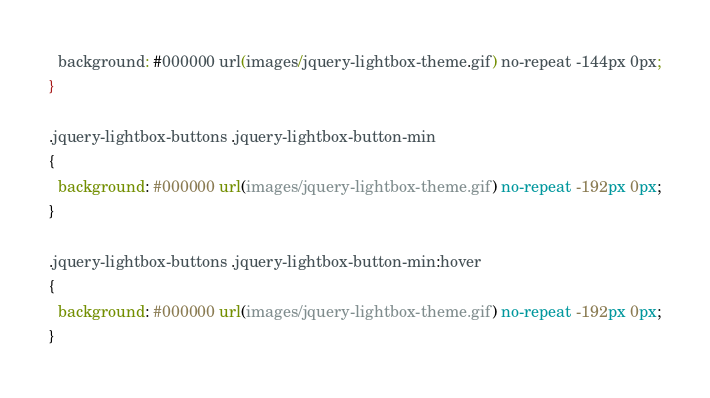<code> <loc_0><loc_0><loc_500><loc_500><_CSS_>  background: #000000 url(images/jquery-lightbox-theme.gif) no-repeat -144px 0px;
}

.jquery-lightbox-buttons .jquery-lightbox-button-min
{
  background: #000000 url(images/jquery-lightbox-theme.gif) no-repeat -192px 0px;
}

.jquery-lightbox-buttons .jquery-lightbox-button-min:hover
{
  background: #000000 url(images/jquery-lightbox-theme.gif) no-repeat -192px 0px;
}</code> 